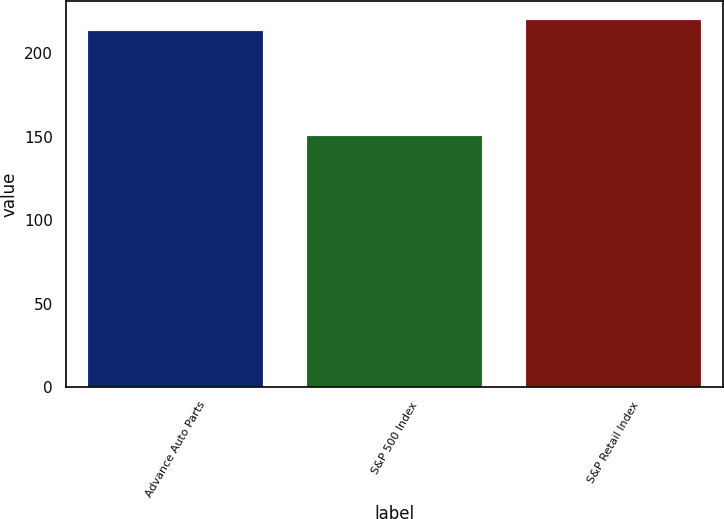Convert chart to OTSL. <chart><loc_0><loc_0><loc_500><loc_500><bar_chart><fcel>Advance Auto Parts<fcel>S&P 500 Index<fcel>S&P Retail Index<nl><fcel>213.14<fcel>150.51<fcel>220.07<nl></chart> 